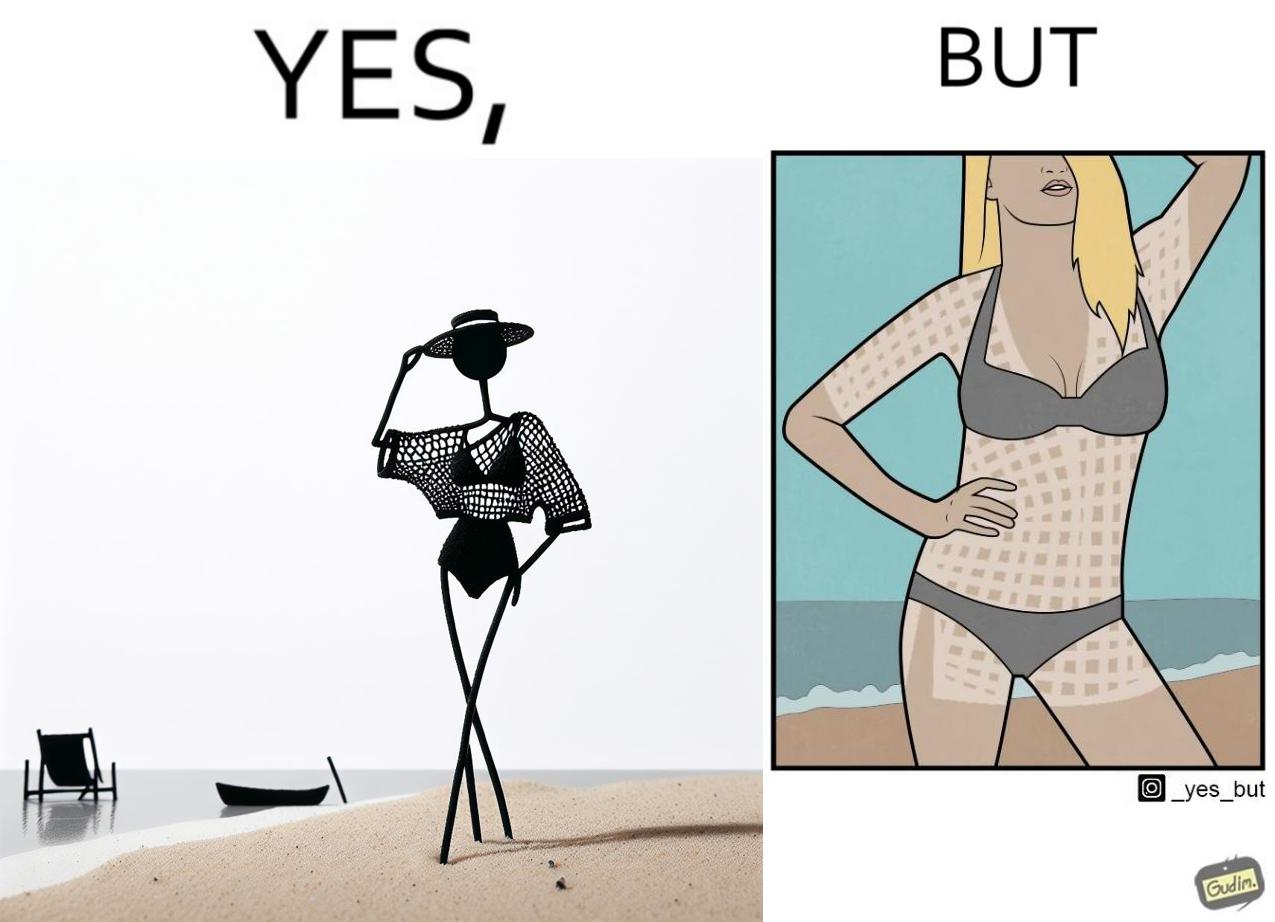Is this a satirical image? Yes, this image is satirical. 